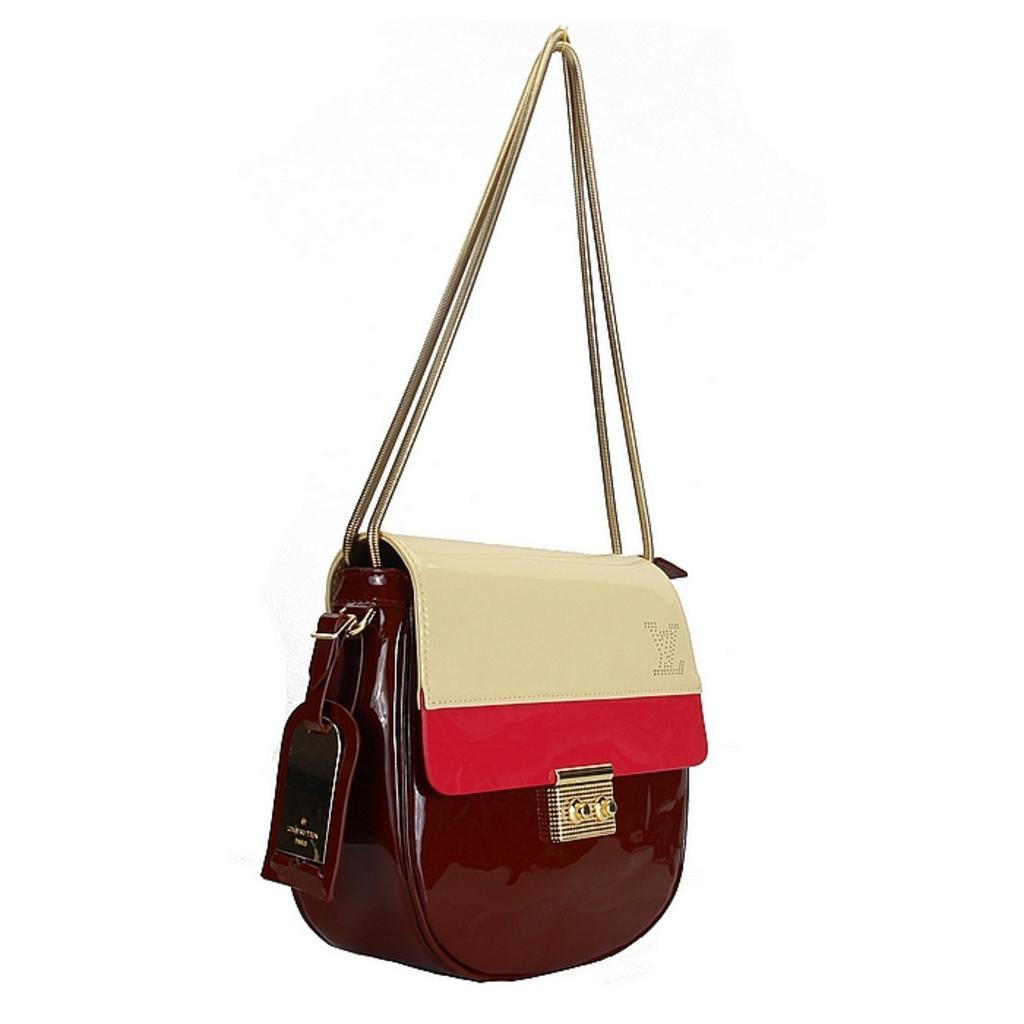Please provide a concise description of this image. We can see brown color hand bag attached with strap and clip. 